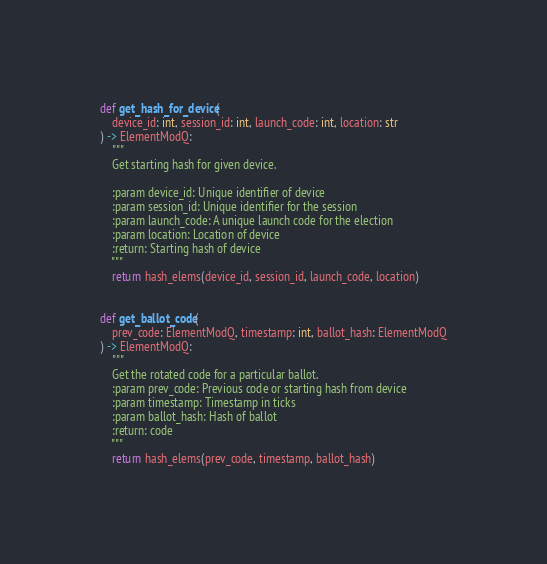Convert code to text. <code><loc_0><loc_0><loc_500><loc_500><_Python_>
def get_hash_for_device(
    device_id: int, session_id: int, launch_code: int, location: str
) -> ElementModQ:
    """
    Get starting hash for given device.

    :param device_id: Unique identifier of device
    :param session_id: Unique identifier for the session
    :param launch_code: A unique launch code for the election
    :param location: Location of device
    :return: Starting hash of device
    """
    return hash_elems(device_id, session_id, launch_code, location)


def get_ballot_code(
    prev_code: ElementModQ, timestamp: int, ballot_hash: ElementModQ
) -> ElementModQ:
    """
    Get the rotated code for a particular ballot.
    :param prev_code: Previous code or starting hash from device
    :param timestamp: Timestamp in ticks
    :param ballot_hash: Hash of ballot
    :return: code
    """
    return hash_elems(prev_code, timestamp, ballot_hash)
</code> 